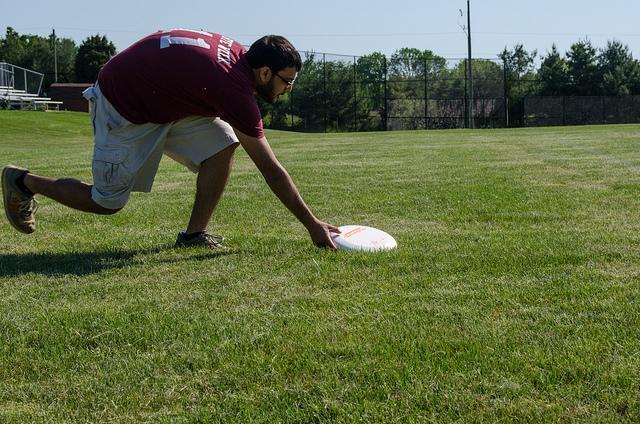How many bottles of soap are by the sinks?
Give a very brief answer. 0. 